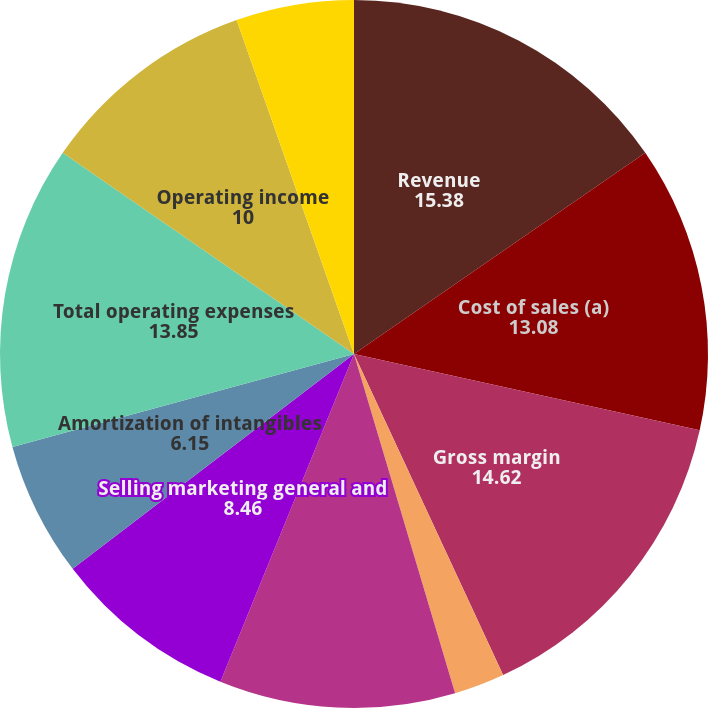Convert chart. <chart><loc_0><loc_0><loc_500><loc_500><pie_chart><fcel>Revenue<fcel>Cost of sales (a)<fcel>Gross margin<fcel>of Revenue<fcel>Research and development<fcel>Selling marketing general and<fcel>Amortization of intangibles<fcel>Total operating expenses<fcel>Operating income<fcel>Interest expense<nl><fcel>15.38%<fcel>13.08%<fcel>14.62%<fcel>2.31%<fcel>10.77%<fcel>8.46%<fcel>6.15%<fcel>13.85%<fcel>10.0%<fcel>5.38%<nl></chart> 